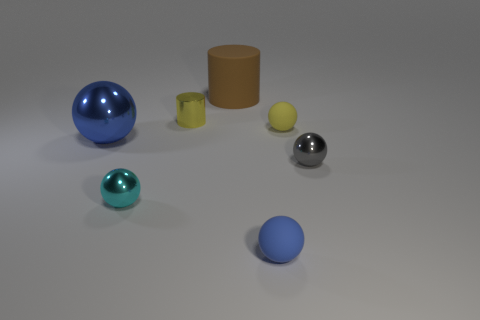Is the ball that is behind the big blue thing made of the same material as the small blue ball?
Keep it short and to the point. Yes. Is the large metallic thing the same shape as the yellow metal object?
Make the answer very short. No. What is the shape of the small rubber thing that is behind the small shiny sphere that is right of the small metal object in front of the tiny gray thing?
Offer a very short reply. Sphere. Is the shape of the rubber thing behind the tiny shiny cylinder the same as the tiny rubber thing that is in front of the large metal sphere?
Give a very brief answer. No. Are there any large purple things made of the same material as the tiny cyan sphere?
Your answer should be compact. No. The tiny matte ball in front of the tiny thing that is to the right of the small yellow matte ball that is in front of the big cylinder is what color?
Keep it short and to the point. Blue. Is the material of the blue object that is left of the big brown matte object the same as the cylinder that is in front of the brown thing?
Offer a terse response. Yes. There is a small object that is in front of the small cyan ball; what is its shape?
Keep it short and to the point. Sphere. How many objects are either brown metallic objects or tiny metallic things in front of the blue shiny ball?
Your answer should be compact. 2. Is the tiny cylinder made of the same material as the tiny gray thing?
Offer a terse response. Yes. 